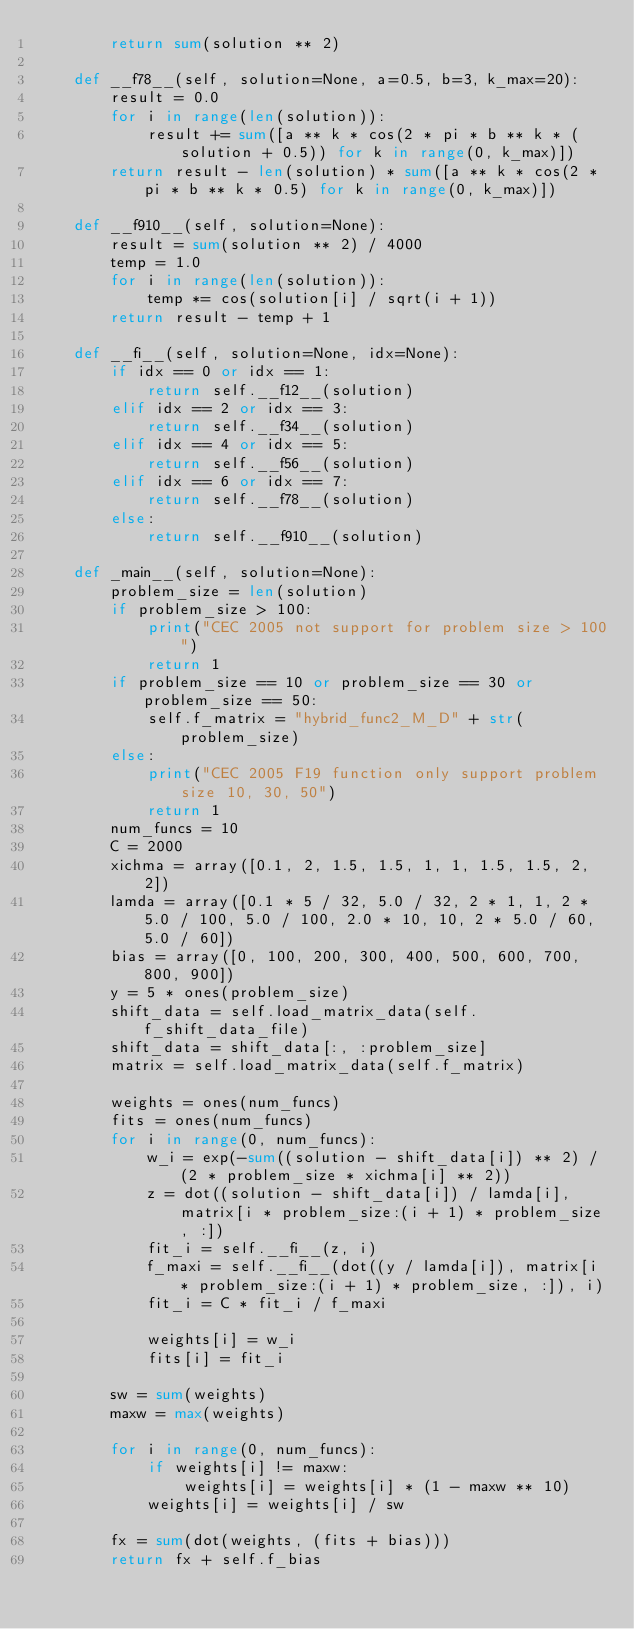<code> <loc_0><loc_0><loc_500><loc_500><_Python_>        return sum(solution ** 2)

    def __f78__(self, solution=None, a=0.5, b=3, k_max=20):
        result = 0.0
        for i in range(len(solution)):
            result += sum([a ** k * cos(2 * pi * b ** k * (solution + 0.5)) for k in range(0, k_max)])
        return result - len(solution) * sum([a ** k * cos(2 * pi * b ** k * 0.5) for k in range(0, k_max)])

    def __f910__(self, solution=None):
        result = sum(solution ** 2) / 4000
        temp = 1.0
        for i in range(len(solution)):
            temp *= cos(solution[i] / sqrt(i + 1))
        return result - temp + 1

    def __fi__(self, solution=None, idx=None):
        if idx == 0 or idx == 1:
            return self.__f12__(solution)
        elif idx == 2 or idx == 3:
            return self.__f34__(solution)
        elif idx == 4 or idx == 5:
            return self.__f56__(solution)
        elif idx == 6 or idx == 7:
            return self.__f78__(solution)
        else:
            return self.__f910__(solution)

    def _main__(self, solution=None):
        problem_size = len(solution)
        if problem_size > 100:
            print("CEC 2005 not support for problem size > 100")
            return 1
        if problem_size == 10 or problem_size == 30 or problem_size == 50:
            self.f_matrix = "hybrid_func2_M_D" + str(problem_size)
        else:
            print("CEC 2005 F19 function only support problem size 10, 30, 50")
            return 1
        num_funcs = 10
        C = 2000
        xichma = array([0.1, 2, 1.5, 1.5, 1, 1, 1.5, 1.5, 2, 2])
        lamda = array([0.1 * 5 / 32, 5.0 / 32, 2 * 1, 1, 2 * 5.0 / 100, 5.0 / 100, 2.0 * 10, 10, 2 * 5.0 / 60, 5.0 / 60])
        bias = array([0, 100, 200, 300, 400, 500, 600, 700, 800, 900])
        y = 5 * ones(problem_size)
        shift_data = self.load_matrix_data(self.f_shift_data_file)
        shift_data = shift_data[:, :problem_size]
        matrix = self.load_matrix_data(self.f_matrix)

        weights = ones(num_funcs)
        fits = ones(num_funcs)
        for i in range(0, num_funcs):
            w_i = exp(-sum((solution - shift_data[i]) ** 2) / (2 * problem_size * xichma[i] ** 2))
            z = dot((solution - shift_data[i]) / lamda[i], matrix[i * problem_size:(i + 1) * problem_size, :])
            fit_i = self.__fi__(z, i)
            f_maxi = self.__fi__(dot((y / lamda[i]), matrix[i * problem_size:(i + 1) * problem_size, :]), i)
            fit_i = C * fit_i / f_maxi

            weights[i] = w_i
            fits[i] = fit_i

        sw = sum(weights)
        maxw = max(weights)

        for i in range(0, num_funcs):
            if weights[i] != maxw:
                weights[i] = weights[i] * (1 - maxw ** 10)
            weights[i] = weights[i] / sw

        fx = sum(dot(weights, (fits + bias)))
        return fx + self.f_bias
</code> 